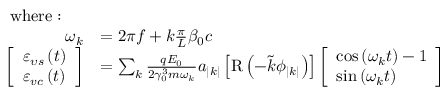Convert formula to latex. <formula><loc_0><loc_0><loc_500><loc_500>\begin{array} { r l } { w h e r e \colon } \\ { \omega _ { k } } & { = 2 \pi f + k \frac { \pi } { L } \beta _ { 0 } c } \\ { \left [ \begin{array} { l } { \varepsilon _ { \upsilon s } \left ( t \right ) } \\ { \varepsilon _ { v c } \left ( t \right ) } \end{array} \right ] } & { = \sum _ { k } \frac { q E _ { 0 } } { 2 \gamma _ { 0 } ^ { 3 } m \omega _ { k } } a _ { \left | k \right | } \left [ R \left ( - \tilde { k } \phi _ { \left | k \right | } \right ) \right ] \left [ \begin{array} { l } { \cos \left ( \omega _ { k } t \right ) - 1 } \\ { \sin \left ( \omega _ { k } t \right ) } \end{array} \right ] } \end{array}</formula> 